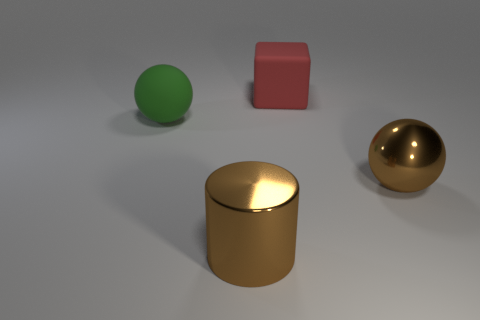How many metallic spheres have the same color as the shiny cylinder?
Offer a terse response. 1. How many things are big spheres that are in front of the big green rubber thing or blue shiny cylinders?
Offer a terse response. 1. There is a large block that is made of the same material as the green ball; what is its color?
Provide a succinct answer. Red. Is there a metallic object that has the same size as the green matte ball?
Keep it short and to the point. Yes. What number of things are either objects that are in front of the brown metallic ball or big rubber things on the right side of the green matte thing?
Your answer should be compact. 2. There is a red thing that is the same size as the green matte ball; what is its shape?
Provide a short and direct response. Cube. Is there a green thing that has the same shape as the red object?
Ensure brevity in your answer.  No. Are there fewer large blocks than brown rubber objects?
Provide a succinct answer. No. Does the thing that is to the right of the big red block have the same size as the ball that is to the left of the red rubber block?
Ensure brevity in your answer.  Yes. How many things are either big green balls or tiny gray metal things?
Give a very brief answer. 1. 